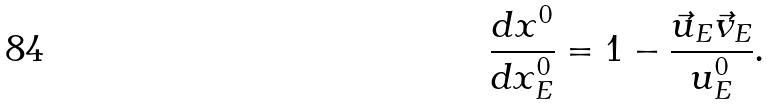Convert formula to latex. <formula><loc_0><loc_0><loc_500><loc_500>\frac { d x ^ { 0 } } { d x _ { E } ^ { 0 } } = 1 - \frac { \vec { u } _ { E } \vec { v } _ { E } } { u _ { E } ^ { 0 } } .</formula> 